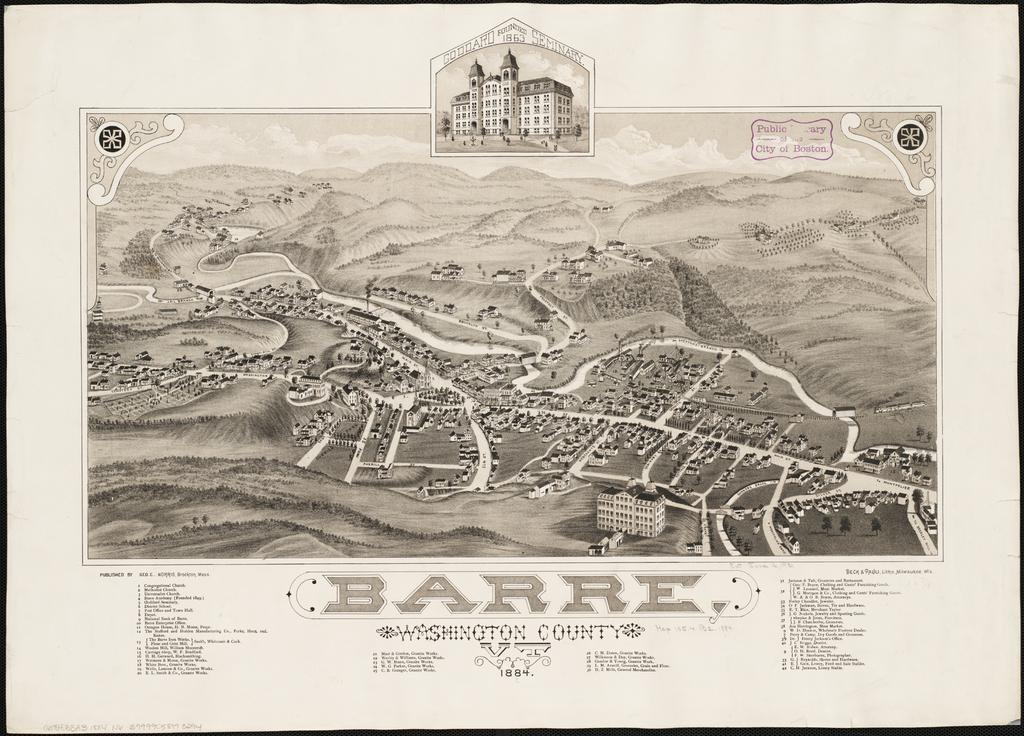Provide a one-sentence caption for the provided image. A map with the caption Barre Washington County. 